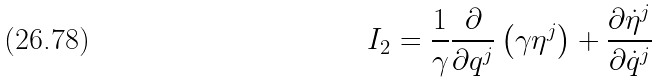<formula> <loc_0><loc_0><loc_500><loc_500>I _ { 2 } = \frac { 1 } { \gamma } \frac { \partial } { \partial q ^ { j } } \left ( \gamma \eta ^ { j } \right ) + \frac { \partial \dot { \eta } ^ { j } } { \partial \dot { q } ^ { j } }</formula> 